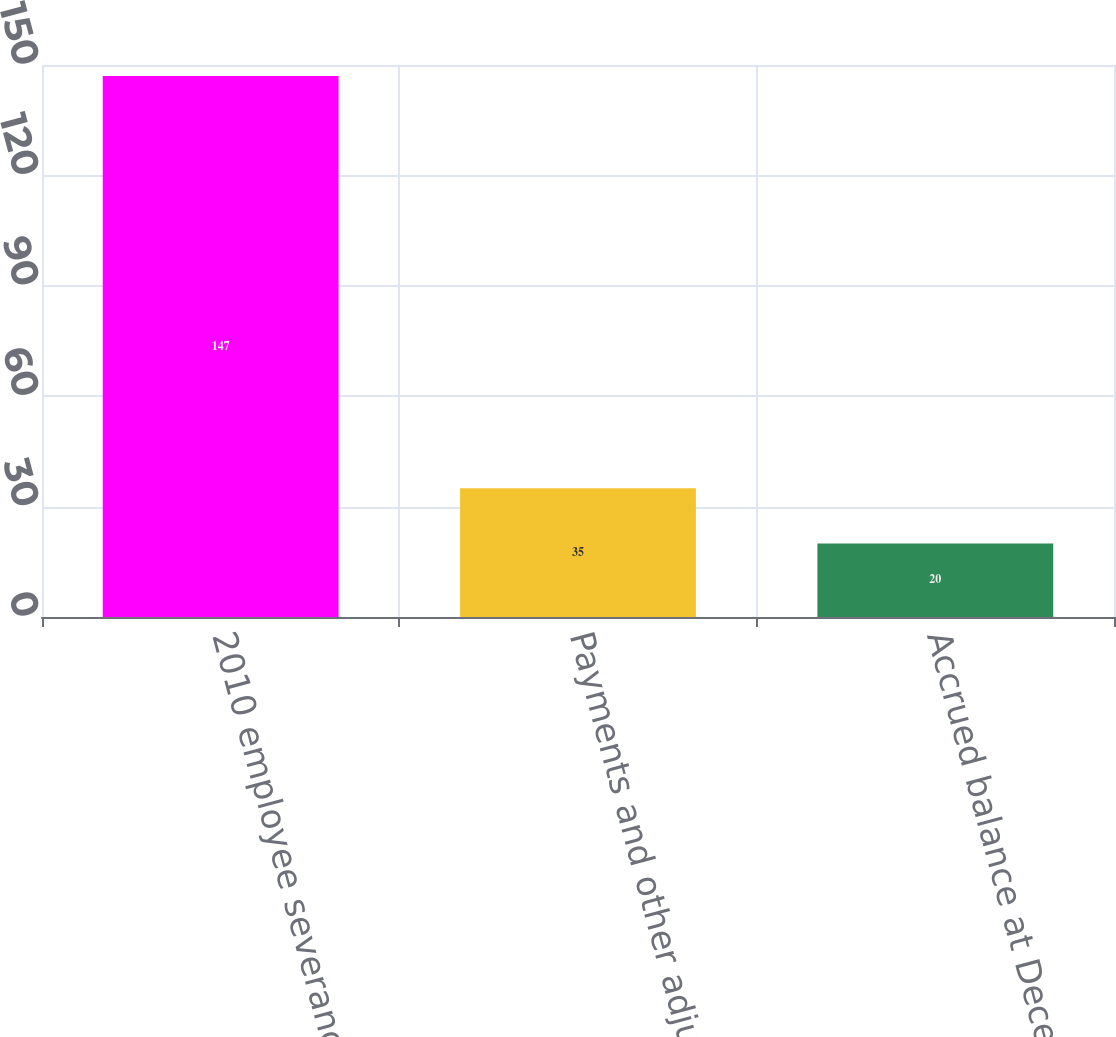Convert chart to OTSL. <chart><loc_0><loc_0><loc_500><loc_500><bar_chart><fcel>2010 employee severance charge<fcel>Payments and other adjustments<fcel>Accrued balance at December 31<nl><fcel>147<fcel>35<fcel>20<nl></chart> 